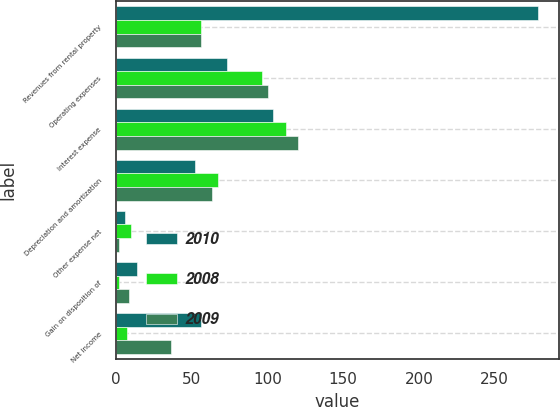Convert chart to OTSL. <chart><loc_0><loc_0><loc_500><loc_500><stacked_bar_chart><ecel><fcel>Revenues from rental property<fcel>Operating expenses<fcel>Interest expense<fcel>Depreciation and amortization<fcel>Other expense net<fcel>Gain on disposition of<fcel>Net income<nl><fcel>2010<fcel>278.4<fcel>73.2<fcel>104<fcel>52.3<fcel>6.3<fcel>13.7<fcel>56.3<nl><fcel>2008<fcel>56.3<fcel>96.7<fcel>112.5<fcel>67.7<fcel>9.7<fcel>1.7<fcel>7<nl><fcel>2009<fcel>56.3<fcel>100.1<fcel>120<fcel>63.7<fcel>1.7<fcel>8.5<fcel>36.3<nl></chart> 